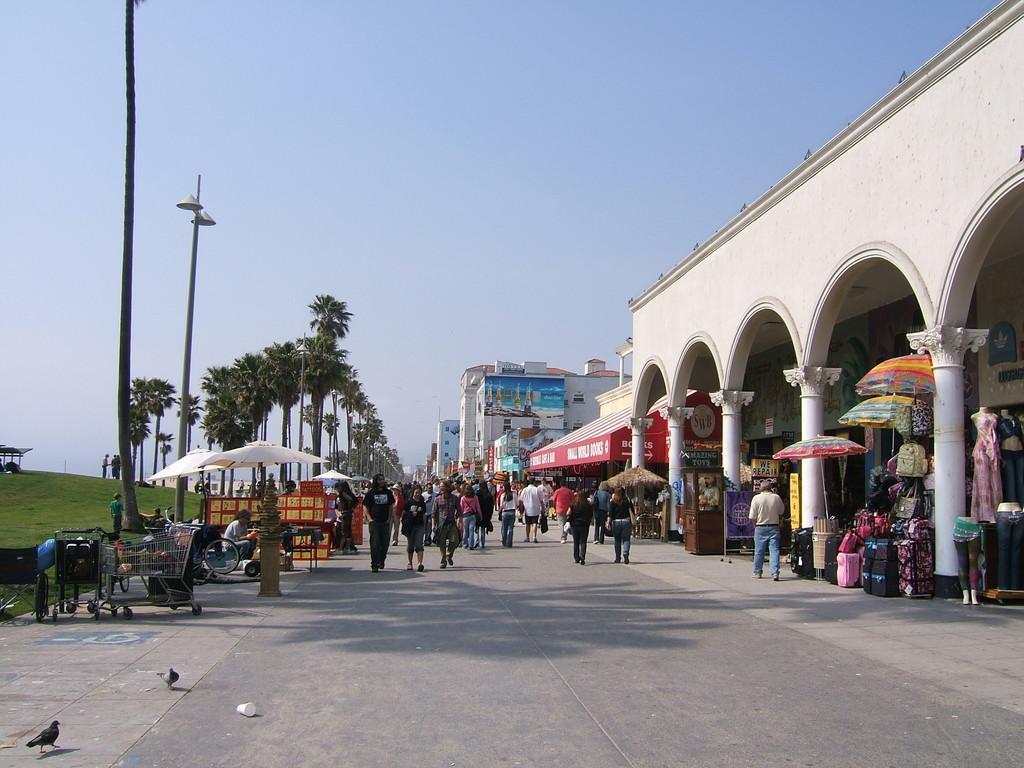Can you describe this image briefly? In the image there is a road in the middle with many people walking on it, on the right side there are buildings, on the left side there are trees on the grass land and above its sky. 